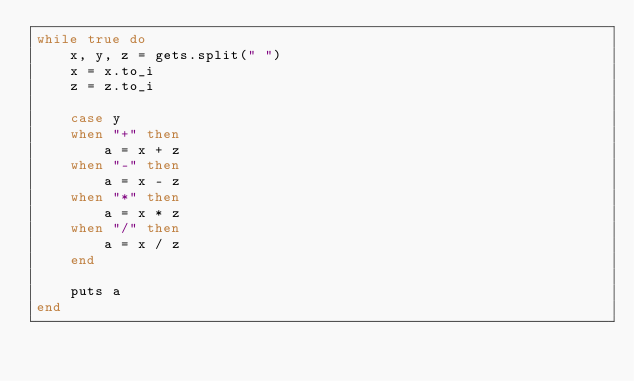Convert code to text. <code><loc_0><loc_0><loc_500><loc_500><_Ruby_>while true do
    x, y, z = gets.split(" ")
    x = x.to_i
    z = z.to_i
    
    case y
    when "+" then
        a = x + z
    when "-" then
        a = x - z
    when "*" then
        a = x * z
    when "/" then
        a = x / z
    end
    
    puts a
end</code> 